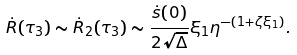<formula> <loc_0><loc_0><loc_500><loc_500>\dot { R } ( \tau _ { 3 } ) \sim \dot { R } _ { 2 } ( \tau _ { 3 } ) \sim \frac { \dot { s } ( 0 ) } { 2 \sqrt { \Delta } } \xi _ { 1 } \eta ^ { - ( 1 + \zeta \xi _ { 1 } ) } .</formula> 